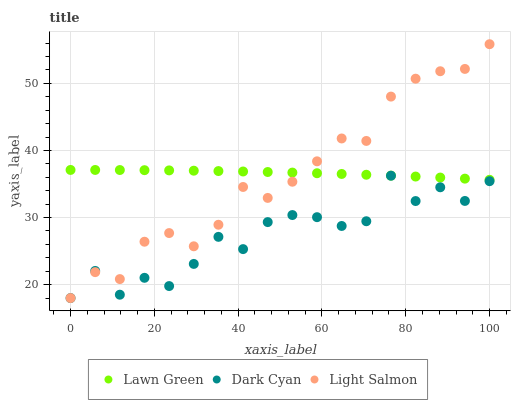Does Dark Cyan have the minimum area under the curve?
Answer yes or no. Yes. Does Lawn Green have the maximum area under the curve?
Answer yes or no. Yes. Does Light Salmon have the minimum area under the curve?
Answer yes or no. No. Does Light Salmon have the maximum area under the curve?
Answer yes or no. No. Is Lawn Green the smoothest?
Answer yes or no. Yes. Is Dark Cyan the roughest?
Answer yes or no. Yes. Is Light Salmon the smoothest?
Answer yes or no. No. Is Light Salmon the roughest?
Answer yes or no. No. Does Dark Cyan have the lowest value?
Answer yes or no. Yes. Does Lawn Green have the lowest value?
Answer yes or no. No. Does Light Salmon have the highest value?
Answer yes or no. Yes. Does Lawn Green have the highest value?
Answer yes or no. No. Is Dark Cyan less than Lawn Green?
Answer yes or no. Yes. Is Lawn Green greater than Dark Cyan?
Answer yes or no. Yes. Does Light Salmon intersect Dark Cyan?
Answer yes or no. Yes. Is Light Salmon less than Dark Cyan?
Answer yes or no. No. Is Light Salmon greater than Dark Cyan?
Answer yes or no. No. Does Dark Cyan intersect Lawn Green?
Answer yes or no. No. 